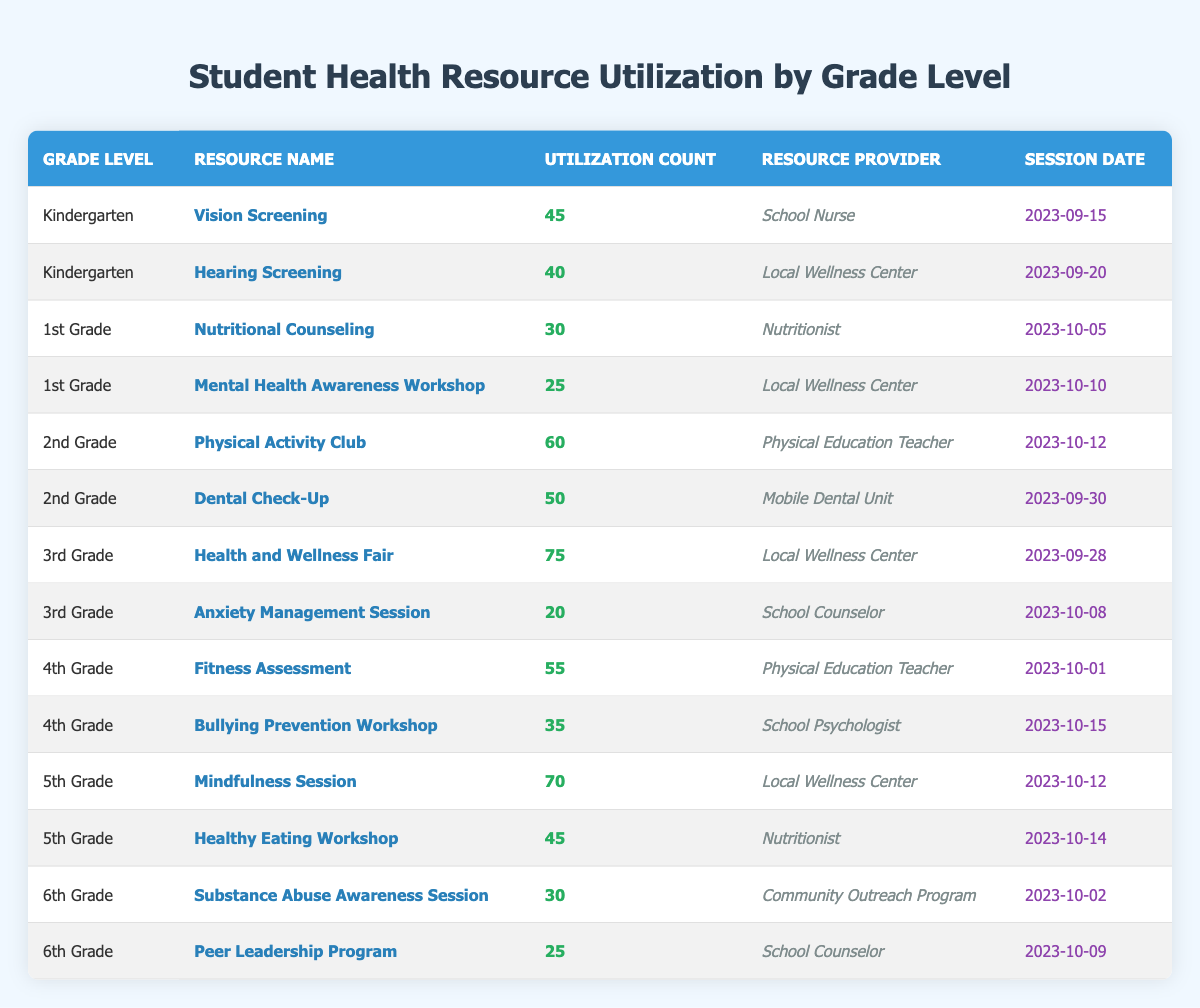What resources were utilized for 1st grade? The table lists two resources for 1st grade: Nutritional Counseling with a utilization count of 30 by the Nutritionist and Mental Health Awareness Workshop with a utilization count of 25 by the Local Wellness Center.
Answer: Nutritional Counseling and Mental Health Awareness Workshop How many students utilized the Physical Activity Club in 2nd grade? The table shows that the Physical Activity Club had a utilization count of 60 for 2nd grade.
Answer: 60 Which resource had the highest utilization in 3rd grade? The Health and Wellness Fair had the highest utilization count of 75, compared to the Anxiety Management Session which had a count of 20.
Answer: Health and Wellness Fair What was the total utilization count for 5th grade resources? The total for 5th grade can be calculated by adding the counts: Mindfulness Session (70) + Healthy Eating Workshop (45) = 115.
Answer: 115 Did 6th grade have more utilization in the Peer Leadership Program than in the Substance Abuse Awareness Session? The Peer Leadership Program had a utilization count of 25 while the Substance Abuse Awareness Session had a count of 30, meaning 6th grade had fewer in the Peer Leadership Program.
Answer: No Which grade level had the highest single resource utilization and what was it? The Health and Wellness Fair for 3rd grade had the highest single utilization count at 75.
Answer: 3rd Grade, 75 What is the average utilization count across all resources for Kindergarten? For Kindergarten, the total utilization is 45 (Vision Screening) + 40 (Hearing Screening) = 85; there are 2 resources, so the average is 85/2 = 42.5.
Answer: 42.5 Are there any resources that the Local Wellness Center provided for 4th grade? The table shows no resources listed for 4th grade that were provided by the Local Wellness Center, which only appears in Kindergarten, 1st grade, 3rd grade, and 5th grade.
Answer: No Which resource had the least utilization count among all grades? The Anxiety Management Session for 3rd grade had the least utilization at 20, which is lower than any other resource in the table.
Answer: Anxiety Management Session, 20 What is the total number of students who utilized health resources provided by nutritionists? The table lists two resources provided by nutritionists: Nutritional Counseling (30) and Healthy Eating Workshop (45). The total is 30 + 45 = 75.
Answer: 75 